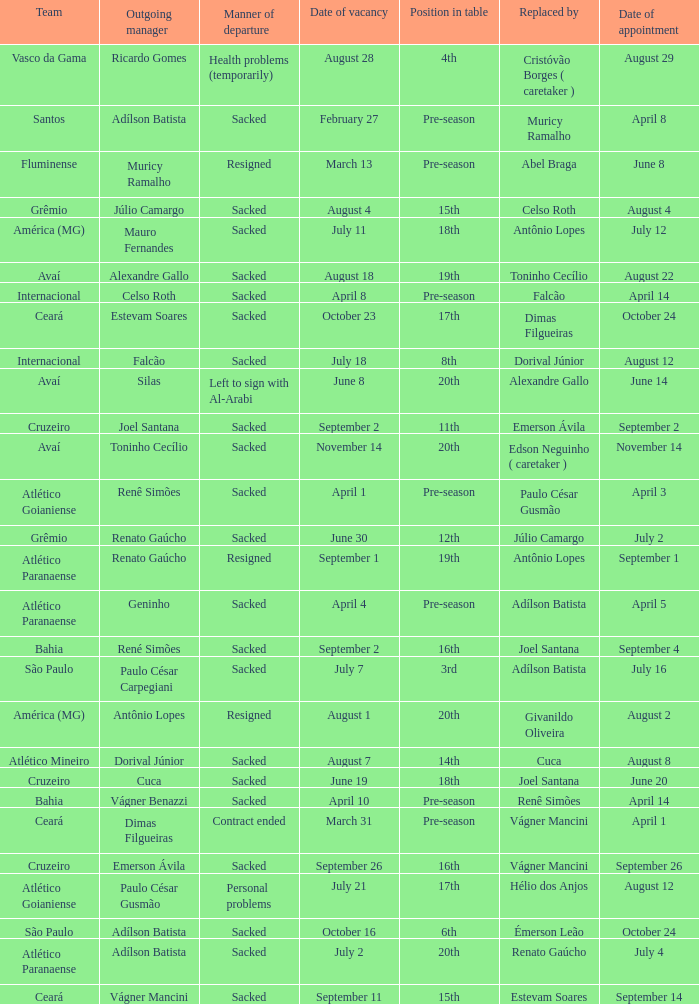How many times did Silas leave as a team manager? 1.0. 